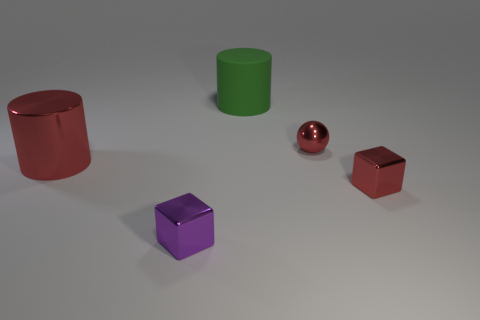Add 1 big red metallic cylinders. How many objects exist? 6 Subtract all green cylinders. Subtract all purple blocks. How many cylinders are left? 1 Subtract all spheres. How many objects are left? 4 Add 2 tiny red blocks. How many tiny red blocks exist? 3 Subtract 0 gray cubes. How many objects are left? 5 Subtract all small spheres. Subtract all small green matte balls. How many objects are left? 4 Add 1 small shiny objects. How many small shiny objects are left? 4 